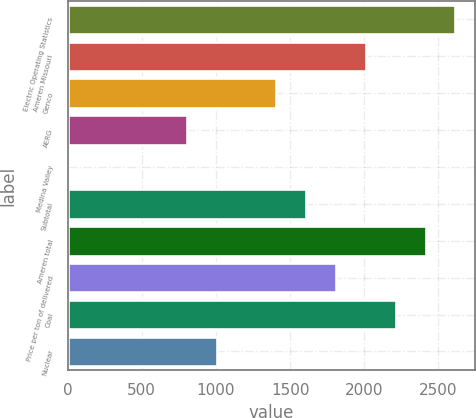Convert chart to OTSL. <chart><loc_0><loc_0><loc_500><loc_500><bar_chart><fcel>Electric Operating Statistics<fcel>Ameren Missouri<fcel>Genco<fcel>AERG<fcel>Medina Valley<fcel>Subtotal<fcel>Ameren total<fcel>Price per ton of delivered<fcel>Coal<fcel>Nuclear<nl><fcel>2614.27<fcel>2011<fcel>1407.73<fcel>804.46<fcel>0.1<fcel>1608.82<fcel>2413.18<fcel>1809.91<fcel>2212.09<fcel>1005.55<nl></chart> 